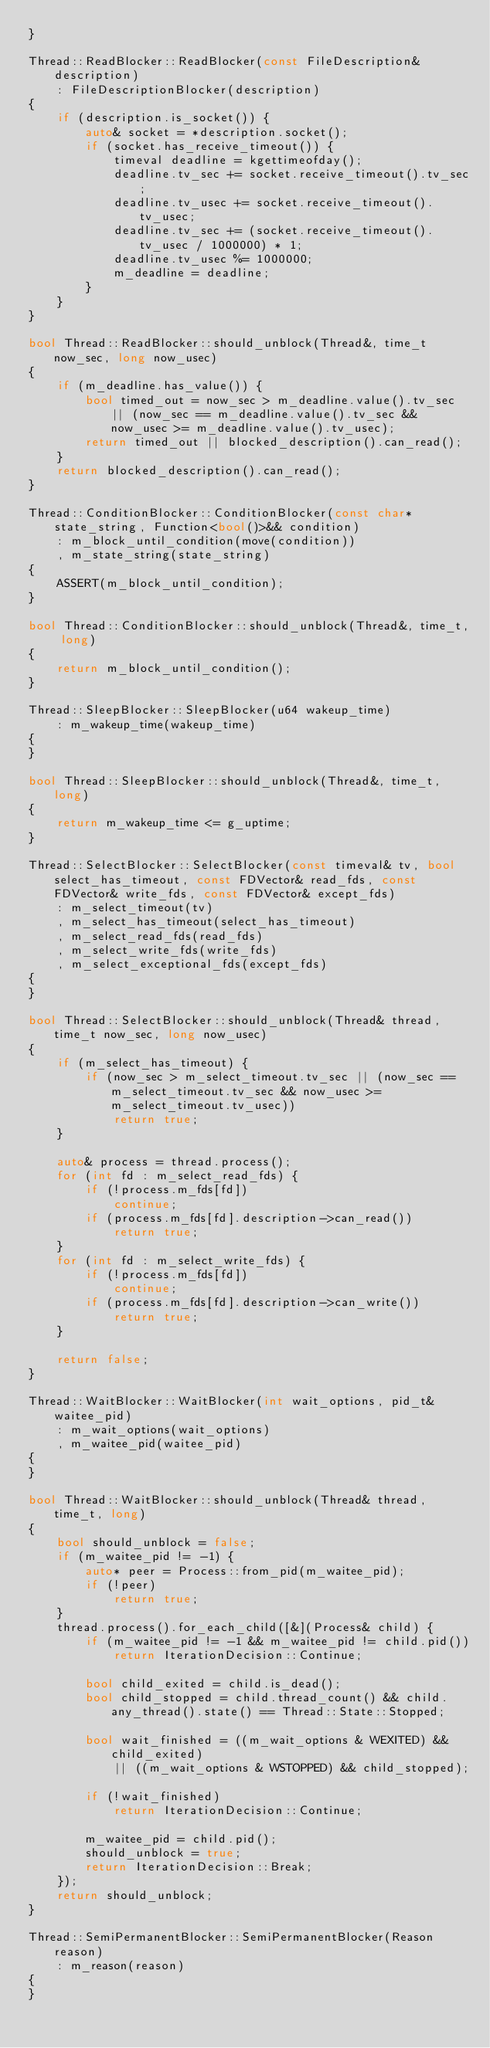<code> <loc_0><loc_0><loc_500><loc_500><_C++_>}

Thread::ReadBlocker::ReadBlocker(const FileDescription& description)
    : FileDescriptionBlocker(description)
{
    if (description.is_socket()) {
        auto& socket = *description.socket();
        if (socket.has_receive_timeout()) {
            timeval deadline = kgettimeofday();
            deadline.tv_sec += socket.receive_timeout().tv_sec;
            deadline.tv_usec += socket.receive_timeout().tv_usec;
            deadline.tv_sec += (socket.receive_timeout().tv_usec / 1000000) * 1;
            deadline.tv_usec %= 1000000;
            m_deadline = deadline;
        }
    }
}

bool Thread::ReadBlocker::should_unblock(Thread&, time_t now_sec, long now_usec)
{
    if (m_deadline.has_value()) {
        bool timed_out = now_sec > m_deadline.value().tv_sec || (now_sec == m_deadline.value().tv_sec && now_usec >= m_deadline.value().tv_usec);
        return timed_out || blocked_description().can_read();
    }
    return blocked_description().can_read();
}

Thread::ConditionBlocker::ConditionBlocker(const char* state_string, Function<bool()>&& condition)
    : m_block_until_condition(move(condition))
    , m_state_string(state_string)
{
    ASSERT(m_block_until_condition);
}

bool Thread::ConditionBlocker::should_unblock(Thread&, time_t, long)
{
    return m_block_until_condition();
}

Thread::SleepBlocker::SleepBlocker(u64 wakeup_time)
    : m_wakeup_time(wakeup_time)
{
}

bool Thread::SleepBlocker::should_unblock(Thread&, time_t, long)
{
    return m_wakeup_time <= g_uptime;
}

Thread::SelectBlocker::SelectBlocker(const timeval& tv, bool select_has_timeout, const FDVector& read_fds, const FDVector& write_fds, const FDVector& except_fds)
    : m_select_timeout(tv)
    , m_select_has_timeout(select_has_timeout)
    , m_select_read_fds(read_fds)
    , m_select_write_fds(write_fds)
    , m_select_exceptional_fds(except_fds)
{
}

bool Thread::SelectBlocker::should_unblock(Thread& thread, time_t now_sec, long now_usec)
{
    if (m_select_has_timeout) {
        if (now_sec > m_select_timeout.tv_sec || (now_sec == m_select_timeout.tv_sec && now_usec >= m_select_timeout.tv_usec))
            return true;
    }

    auto& process = thread.process();
    for (int fd : m_select_read_fds) {
        if (!process.m_fds[fd])
            continue;
        if (process.m_fds[fd].description->can_read())
            return true;
    }
    for (int fd : m_select_write_fds) {
        if (!process.m_fds[fd])
            continue;
        if (process.m_fds[fd].description->can_write())
            return true;
    }

    return false;
}

Thread::WaitBlocker::WaitBlocker(int wait_options, pid_t& waitee_pid)
    : m_wait_options(wait_options)
    , m_waitee_pid(waitee_pid)
{
}

bool Thread::WaitBlocker::should_unblock(Thread& thread, time_t, long)
{
    bool should_unblock = false;
    if (m_waitee_pid != -1) {
        auto* peer = Process::from_pid(m_waitee_pid);
        if (!peer)
            return true;
    }
    thread.process().for_each_child([&](Process& child) {
        if (m_waitee_pid != -1 && m_waitee_pid != child.pid())
            return IterationDecision::Continue;

        bool child_exited = child.is_dead();
        bool child_stopped = child.thread_count() && child.any_thread().state() == Thread::State::Stopped;

        bool wait_finished = ((m_wait_options & WEXITED) && child_exited)
            || ((m_wait_options & WSTOPPED) && child_stopped);

        if (!wait_finished)
            return IterationDecision::Continue;

        m_waitee_pid = child.pid();
        should_unblock = true;
        return IterationDecision::Break;
    });
    return should_unblock;
}

Thread::SemiPermanentBlocker::SemiPermanentBlocker(Reason reason)
    : m_reason(reason)
{
}
</code> 